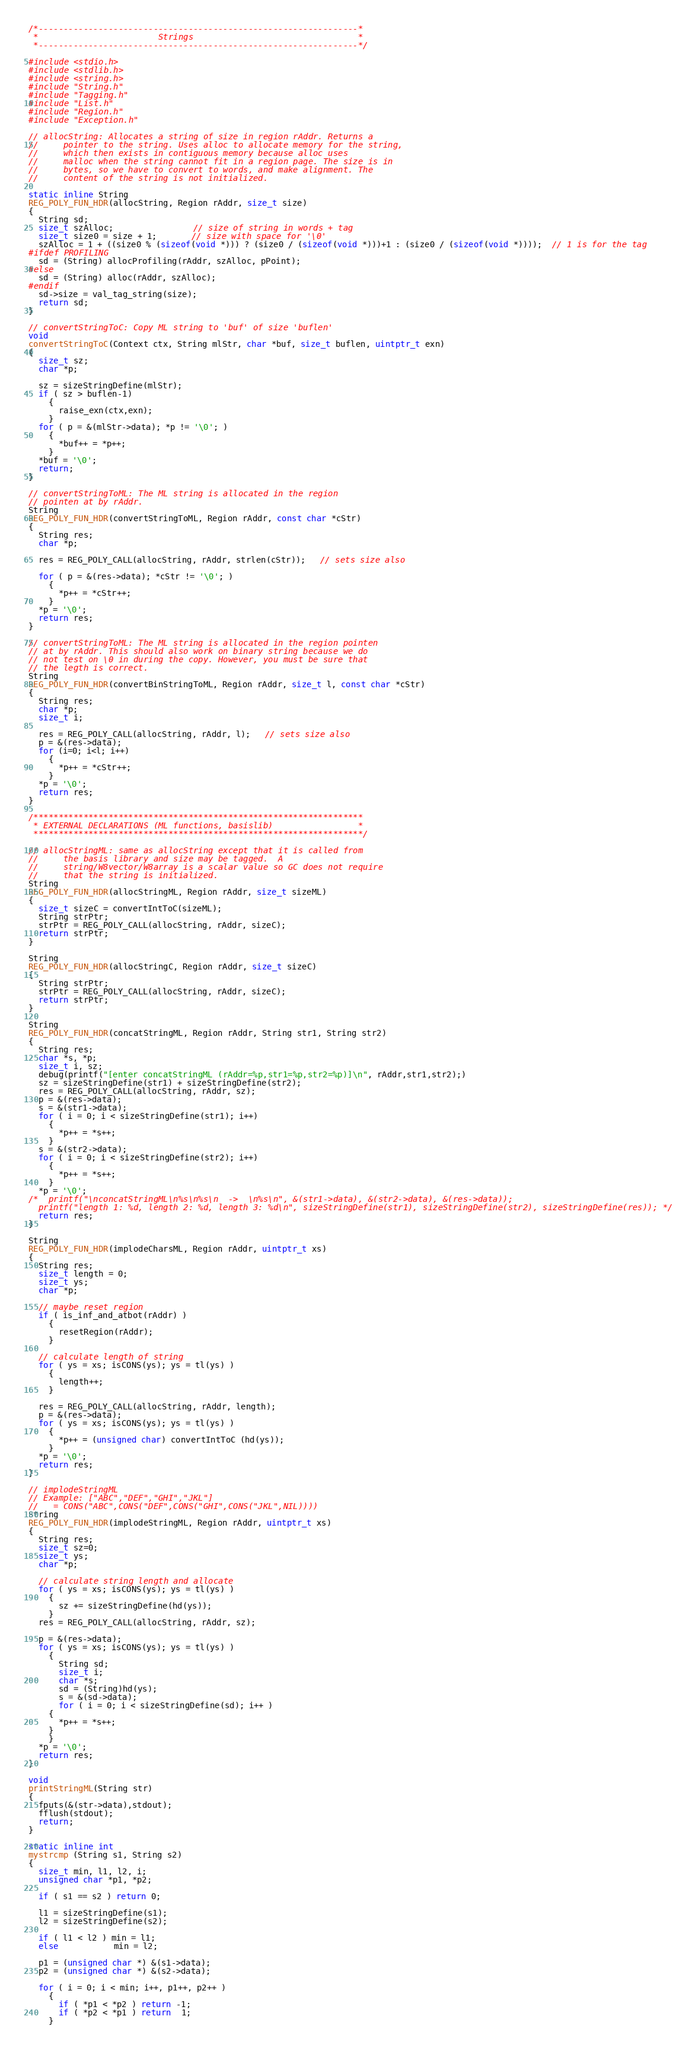<code> <loc_0><loc_0><loc_500><loc_500><_C_>/*----------------------------------------------------------------*
 *                        Strings                                 *
 *----------------------------------------------------------------*/

#include <stdio.h>
#include <stdlib.h>
#include <string.h>
#include "String.h"
#include "Tagging.h"
#include "List.h"
#include "Region.h"
#include "Exception.h"

// allocString: Allocates a string of size in region rAddr. Returns a
//     pointer to the string. Uses alloc to allocate memory for the string,
//     which then exists in contiguous memory because alloc uses
//     malloc when the string cannot fit in a region page. The size is in
//     bytes, so we have to convert to words, and make alignment. The
//     content of the string is not initialized.

static inline String
REG_POLY_FUN_HDR(allocString, Region rAddr, size_t size)
{
  String sd;
  size_t szAlloc;                // size of string in words + tag
  size_t size0 = size + 1;       // size with space for '\0'
  szAlloc = 1 + ((size0 % (sizeof(void *))) ? (size0 / (sizeof(void *)))+1 : (size0 / (sizeof(void *))));  // 1 is for the tag
#ifdef PROFILING
  sd = (String) allocProfiling(rAddr, szAlloc, pPoint);
#else
  sd = (String) alloc(rAddr, szAlloc);
#endif
  sd->size = val_tag_string(size);
  return sd;
}

// convertStringToC: Copy ML string to 'buf' of size 'buflen'
void
convertStringToC(Context ctx, String mlStr, char *buf, size_t buflen, uintptr_t exn)
{
  size_t sz;
  char *p;

  sz = sizeStringDefine(mlStr);
  if ( sz > buflen-1)
    {
      raise_exn(ctx,exn);
    }
  for ( p = &(mlStr->data); *p != '\0'; )
    {
      *buf++ = *p++;
    }
  *buf = '\0';
  return;
}

// convertStringToML: The ML string is allocated in the region
// pointen at by rAddr.
String
REG_POLY_FUN_HDR(convertStringToML, Region rAddr, const char *cStr)
{
  String res;
  char *p;

  res = REG_POLY_CALL(allocString, rAddr, strlen(cStr));   // sets size also

  for ( p = &(res->data); *cStr != '\0'; )
    {
      *p++ = *cStr++;
    }
  *p = '\0';
  return res;
}

// convertStringToML: The ML string is allocated in the region pointen
// at by rAddr. This should also work on binary string because we do
// not test on \0 in during the copy. However, you must be sure that
// the legth is correct.
String
REG_POLY_FUN_HDR(convertBinStringToML, Region rAddr, size_t l, const char *cStr)
{
  String res;
  char *p;
  size_t i;

  res = REG_POLY_CALL(allocString, rAddr, l);   // sets size also
  p = &(res->data);
  for (i=0; i<l; i++)
    {
      *p++ = *cStr++;
    }
  *p = '\0';
  return res;
}

/******************************************************************
 * EXTERNAL DECLARATIONS (ML functions, basislib)                 *
 ******************************************************************/

// allocStringML: same as allocString except that it is called from
//     the basis library and size may be tagged.  A
//     string/W8vector/W8array is a scalar value so GC does not require
//     that the string is initialized.
String
REG_POLY_FUN_HDR(allocStringML, Region rAddr, size_t sizeML)
{
  size_t sizeC = convertIntToC(sizeML);
  String strPtr;
  strPtr = REG_POLY_CALL(allocString, rAddr, sizeC);
  return strPtr;
}

String
REG_POLY_FUN_HDR(allocStringC, Region rAddr, size_t sizeC)
{
  String strPtr;
  strPtr = REG_POLY_CALL(allocString, rAddr, sizeC);
  return strPtr;
}

String
REG_POLY_FUN_HDR(concatStringML, Region rAddr, String str1, String str2)
{
  String res;
  char *s, *p;
  size_t i, sz;
  debug(printf("[enter concatStringML (rAddr=%p,str1=%p,str2=%p)]\n", rAddr,str1,str2);)
  sz = sizeStringDefine(str1) + sizeStringDefine(str2);
  res = REG_POLY_CALL(allocString, rAddr, sz);
  p = &(res->data);
  s = &(str1->data);
  for ( i = 0; i < sizeStringDefine(str1); i++)
    {
      *p++ = *s++;
    }
  s = &(str2->data);
  for ( i = 0; i < sizeStringDefine(str2); i++)
    {
      *p++ = *s++;
    }
  *p = '\0';
/*  printf("\nconcatStringML\n%s\n%s\n  ->  \n%s\n", &(str1->data), &(str2->data), &(res->data));
  printf("length 1: %d, length 2: %d, length 3: %d\n", sizeStringDefine(str1), sizeStringDefine(str2), sizeStringDefine(res)); */
  return res;
}

String
REG_POLY_FUN_HDR(implodeCharsML, Region rAddr, uintptr_t xs)
{
  String res;
  size_t length = 0;
  size_t ys;
  char *p;

  // maybe reset region
  if ( is_inf_and_atbot(rAddr) )
    {
      resetRegion(rAddr);
    }

  // calculate length of string
  for ( ys = xs; isCONS(ys); ys = tl(ys) )
    {
      length++;
    }

  res = REG_POLY_CALL(allocString, rAddr, length);
  p = &(res->data);
  for ( ys = xs; isCONS(ys); ys = tl(ys) )
    {
      *p++ = (unsigned char) convertIntToC (hd(ys));
    }
  *p = '\0';
  return res;
}

// implodeStringML
// Example: ["ABC","DEF","GHI","JKL"]
//   = CONS("ABC",CONS("DEF",CONS("GHI",CONS("JKL",NIL))))
String
REG_POLY_FUN_HDR(implodeStringML, Region rAddr, uintptr_t xs)
{
  String res;
  size_t sz=0;
  size_t ys;
  char *p;

  // calculate string length and allocate
  for ( ys = xs; isCONS(ys); ys = tl(ys) )
    {
      sz += sizeStringDefine(hd(ys));
    }
  res = REG_POLY_CALL(allocString, rAddr, sz);

  p = &(res->data);
  for ( ys = xs; isCONS(ys); ys = tl(ys) )
    {
      String sd;
      size_t i;
      char *s;
      sd = (String)hd(ys);
      s = &(sd->data);
      for ( i = 0; i < sizeStringDefine(sd); i++ )
	{
	  *p++ = *s++;
	}
    }
  *p = '\0';
  return res;
}

void
printStringML(String str)
{
  fputs(&(str->data),stdout);
  fflush(stdout);
  return;
}

static inline int
mystrcmp (String s1, String s2)
{
  size_t min, l1, l2, i;
  unsigned char *p1, *p2;

  if ( s1 == s2 ) return 0;

  l1 = sizeStringDefine(s1);
  l2 = sizeStringDefine(s2);

  if ( l1 < l2 ) min = l1;
  else           min = l2;

  p1 = (unsigned char *) &(s1->data);
  p2 = (unsigned char *) &(s2->data);

  for ( i = 0; i < min; i++, p1++, p2++ )
    {
      if ( *p1 < *p2 ) return -1;
      if ( *p2 < *p1 ) return  1;
    }</code> 